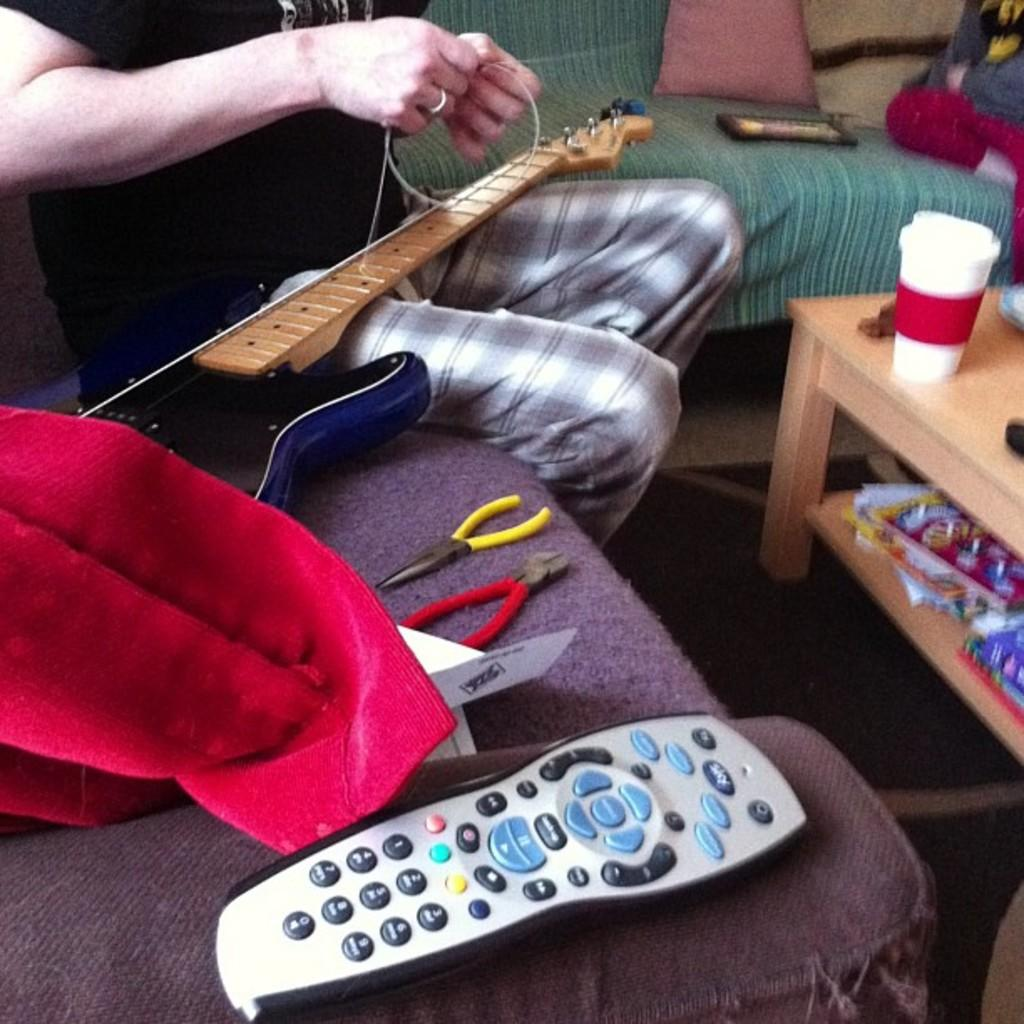<image>
Create a compact narrative representing the image presented. A man restrings a guitar next to a remote control that has a button for Sky and the numbers 1-9 and 0 on the keypad 